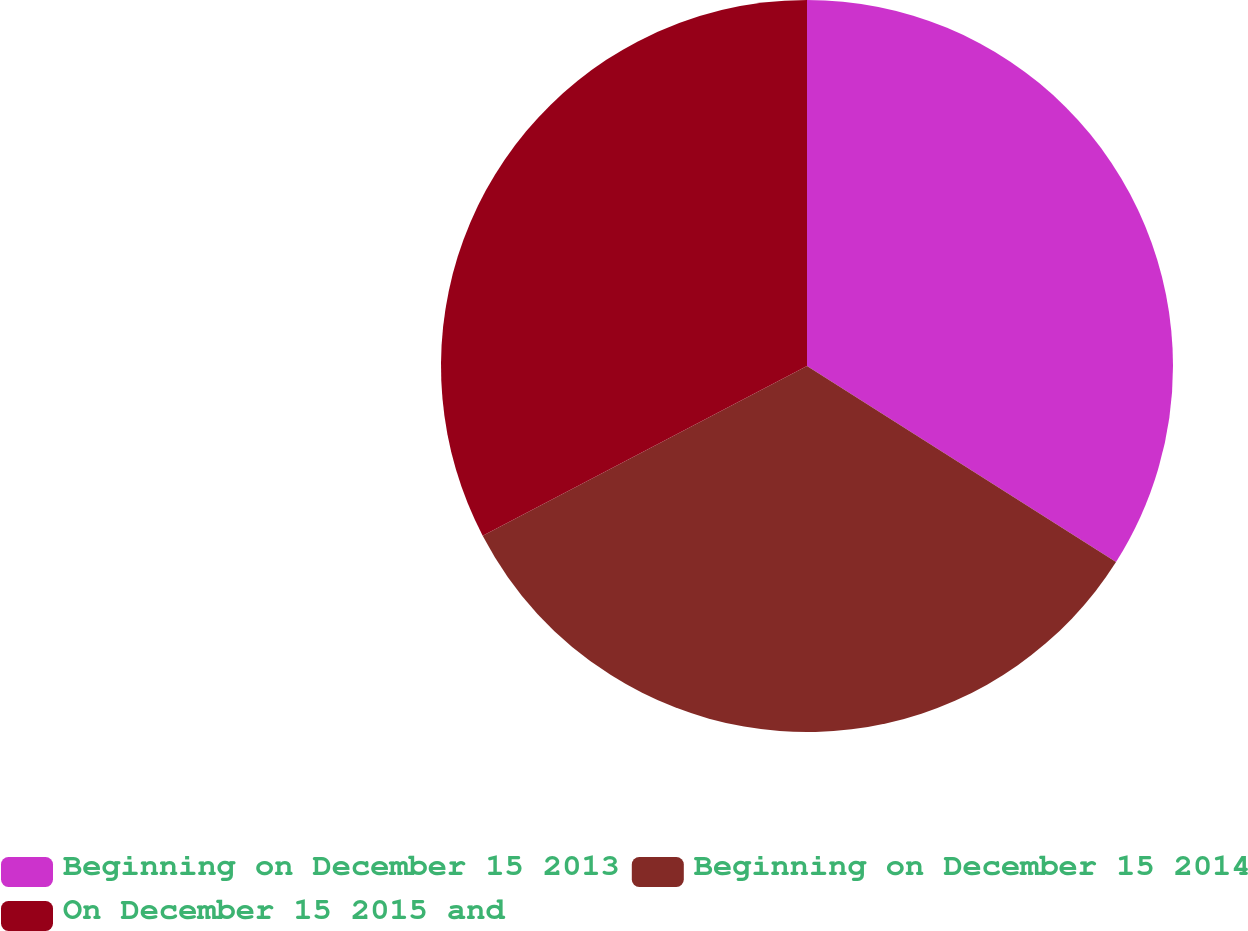<chart> <loc_0><loc_0><loc_500><loc_500><pie_chart><fcel>Beginning on December 15 2013<fcel>Beginning on December 15 2014<fcel>On December 15 2015 and<nl><fcel>34.0%<fcel>33.33%<fcel>32.67%<nl></chart> 